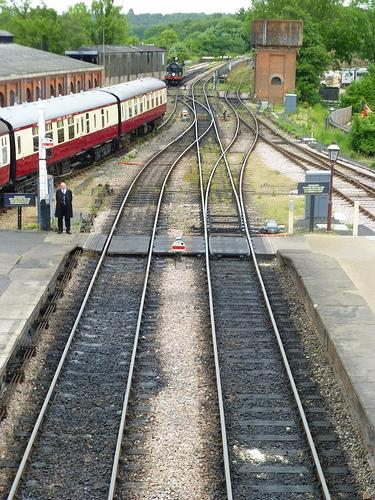What is the color combination of the train engine in the image? The train engine is black and red. How many train tracks are visible in the image, and what is their size? There are many sets of train tracks, with a size of Width: 363 and Height: 363. Identify the color of the platform and its dimensions. The train platform is grey with Width: 75 and Height: 75. Mention the color and size of the lamp post in the image. The lamp post is narrow, brown and has a size of Width: 14, Height: 14. What is the color and size of the gravel under the train tracks? The gravel under the train tracks is black with Width: 347 and Height: 347. Provide a brief overview of the scene depicted in the image. A man is standing on a train platform with many train tracks, a rural railroad station, and green trees behind the train station. Describe the surroundings of the train station, including the type of vegetation. The train station is surrounded by green trees, train tracks, and a rural railroad station. Discover the hidden treasure chest beneath the black gravel on the train tracks. There is no mention of a treasure chest in the image information, and it is unlikely for a treasure chest to be hidden beneath the gravel on train tracks. What is the platform made of? grey material Imagine and describe a possible future event in the scene. The black and red train engine approaches the station while the man checks his watch, anticipating its arrival. How many directions do the rails go in? opposite directions Can you spot the large purple elephant beside the man wearing the black suit? There is no mention of an elephant in the image information and seeing a large purple elephant next to a man is unrealistic. Identify a blue UFO hovering over the train station with a black roof. There is no information in the image about a UFO, and UFOs are not a common occurrence in real life. What is under the train tracks? black gravel Notice the superhero flying above the rails where the trains go in opposite directions? There is no indication of a superhero in the image information, and superheroes are fictional characters, not typically found in ordinary train station scenes. What's along the tracks near the trees? A rural railroad station and a utility building. Describe the scene with a focus on the man and his surroundings. A man wearing a black suit and white shirt is standing on a grey train platform next to a white pole with train tracks, trains, and green trees nearby. What information is written on the blue sign? Cannot identify due to low resolution. Describe the sign located between the train tracks. It's a white and red sign. Name an event occurring at the end of the platform. A man is standing next to a sign. What are the different color combinations of the trains? White and red, black and red. Find a group of children playing soccer on the train platform. There is no mention of children or a soccer game in the image information, and it would be unsafe for children to play soccer on a train platform. Locate a tall giraffe standing behind the green trees near the train tracks. There is no mention of a giraffe in the image information, and it is unlikely for a giraffe to be present near train tracks in real life. What color is the man's suit who is standing on the pavement? black What is happening in the image at the train station? A man is standing on the platform near multiple train tracks with a white and red passenger train, and a black and red train engine. What type of building is pictured along the tracks? utility building What do you observe in the distance involving the train? A black and red train engine sits on the track. Which type of pole is the man standing next to? white pole Identify and describe the key components in the image. A man standing on the platform, train tracks with a white and red passenger train, a black and red train engine, an information sign, and green trees. Describe the scene with a focus on the train tracks and the trains. Many sets of train tracks with a white and red passenger train, a black and red train engine, and train cars on them surrounded by black gravel and green trees. 